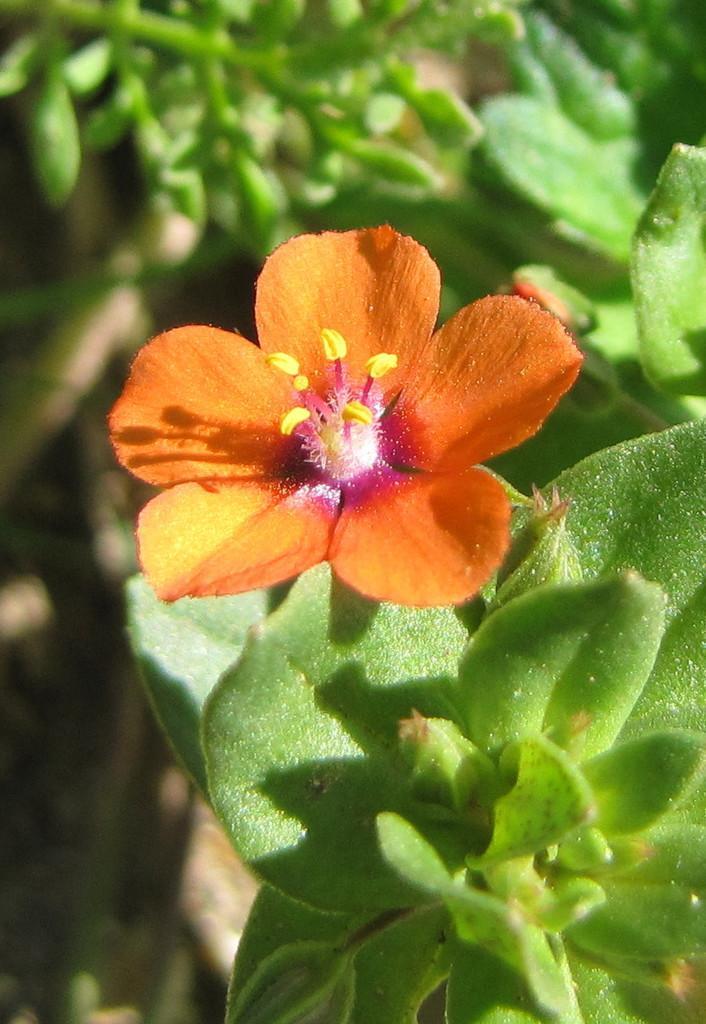Please provide a concise description of this image. In the foreground of the picture we can see leaves and flower. In the background there is greenery and mostly it is blurred. 